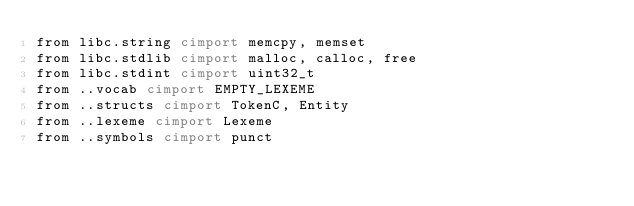<code> <loc_0><loc_0><loc_500><loc_500><_Cython_>from libc.string cimport memcpy, memset
from libc.stdlib cimport malloc, calloc, free
from libc.stdint cimport uint32_t
from ..vocab cimport EMPTY_LEXEME
from ..structs cimport TokenC, Entity
from ..lexeme cimport Lexeme
from ..symbols cimport punct</code> 